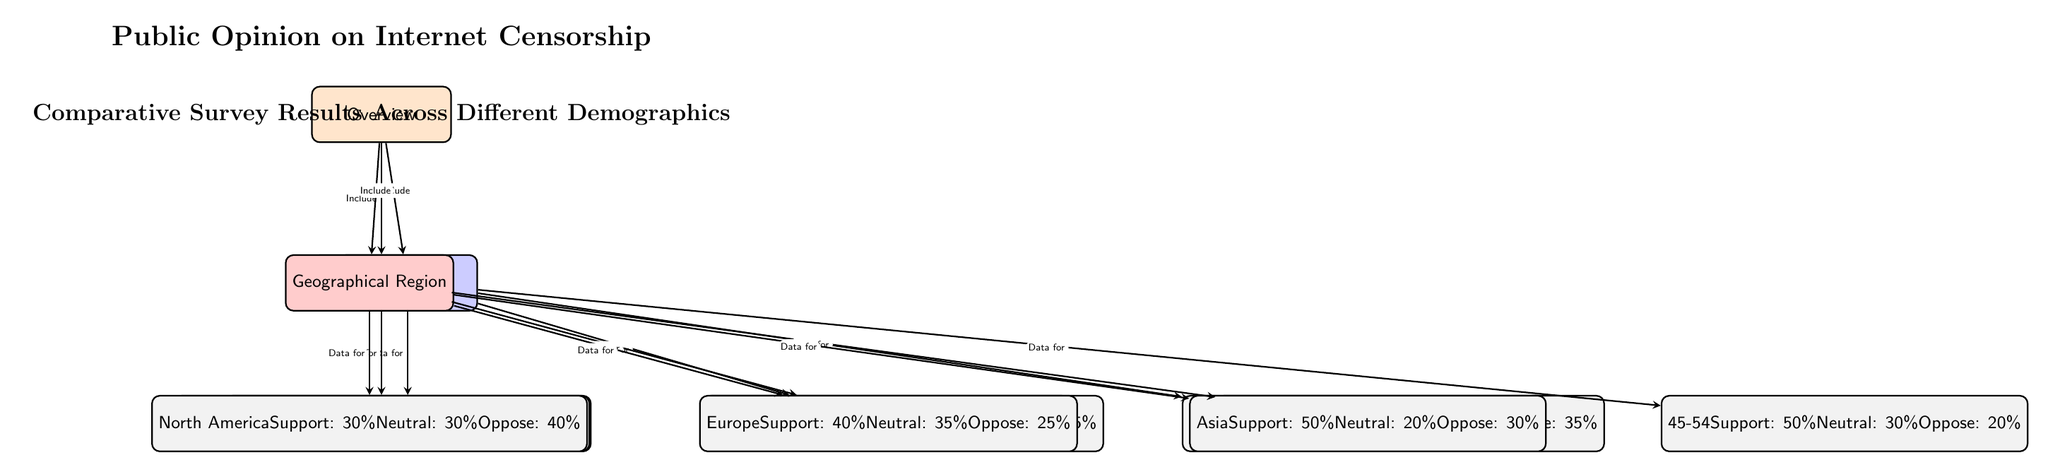What is the percentage of 18-24 year-olds who oppose internet censorship? The node representing the age group 18-24 indicates that 35% of this demographic opposes internet censorship.
Answer: 35% Which educational group has the highest support for internet censorship? The educational node for High School shows 55% support, which is higher than support percentages for Bachelor's and Master's groups.
Answer: High School What is the percentage of support from the 35-44 age group? The node for the age group 35-44 states that 45% of individuals in this age range support internet censorship.
Answer: 45% Which region has the lowest percentage of support for internet censorship? Observing the nodes for geographical regions, North America indicates 30% support, which is lower than the support percentages in Europe and Asia.
Answer: North America What is the combined percentage of people in the 25-34 age group that are neutral or oppose internet censorship? The 25-34 age group's neutral percentage is 25%, and the opposing percentage is 35%. Adding these gives a total of 60% combined for neutral and oppose categories.
Answer: 60% How many total demographic categories are represented in the diagram? The diagram includes three demographic categories: Age Groups, Education Level, and Geographical Region, counted separately as the main nodes.
Answer: 3 Which age group has the highest percentage of opposition to internet censorship? The age group 45-54 states that 20% oppose internet censorship, which is the lowest opposition; other age groups indicate higher opposing percentages — thus, 35% is indicated for the age groups.
Answer: 20% What is the total percentage of individuals with a Master's degree who are neutral towards internet censorship? The Master's node specifically shows a neutral percentage of 30%. Thus, this is the total number for this demographic regarding neutrality.
Answer: 30% In which region is the support for internet censorship the highest? The region Asia shows the highest percentage of support at 50%, as indicated by its node, comparing to North America and Europe.
Answer: Asia 